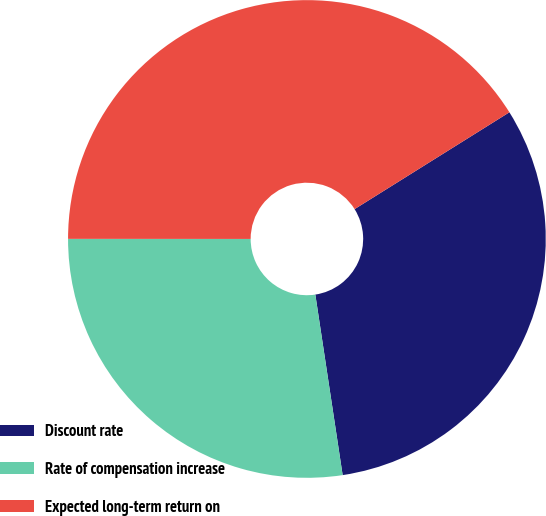Convert chart to OTSL. <chart><loc_0><loc_0><loc_500><loc_500><pie_chart><fcel>Discount rate<fcel>Rate of compensation increase<fcel>Expected long-term return on<nl><fcel>31.51%<fcel>27.4%<fcel>41.1%<nl></chart> 